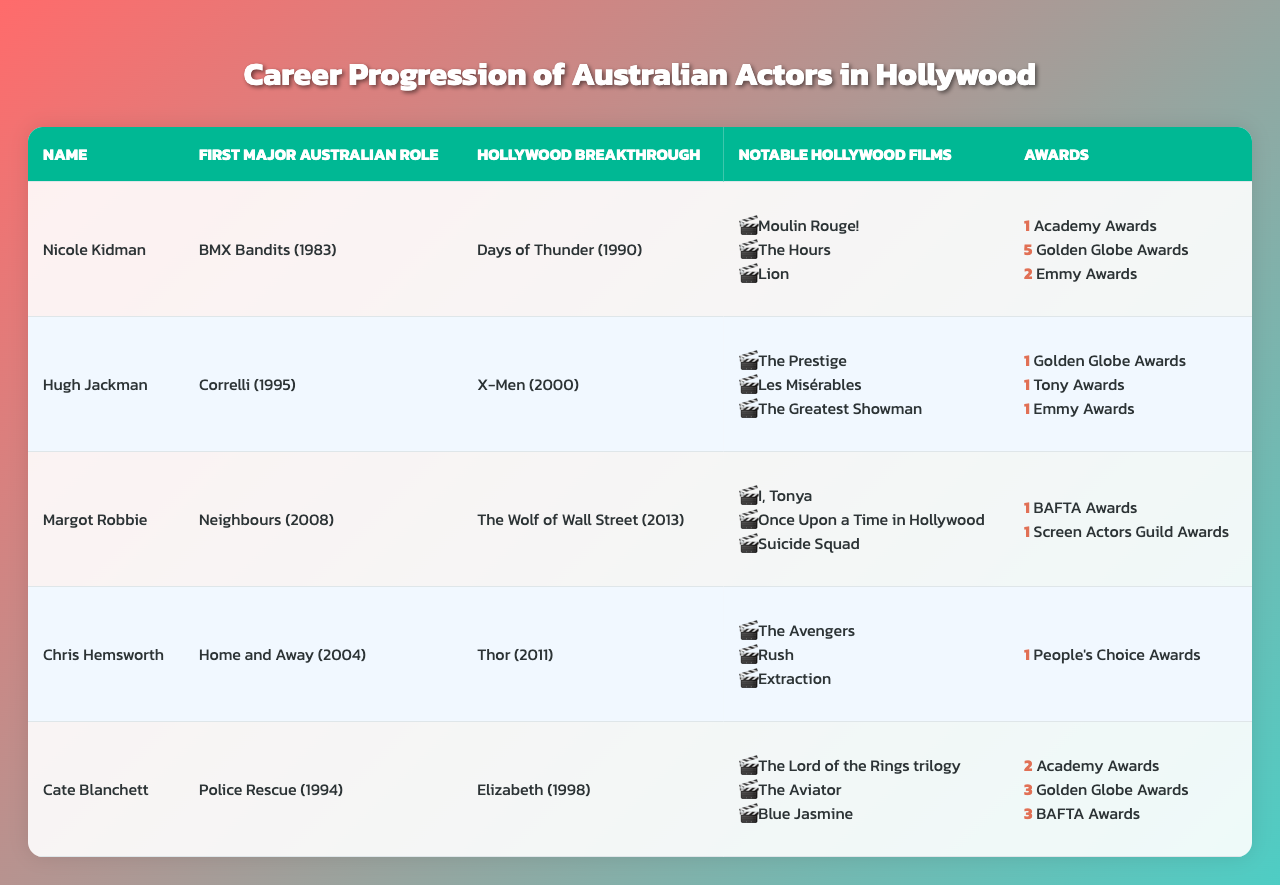What is the first major Australian role of Hugh Jackman? The table shows that Hugh Jackman's first major Australian role was in "Correlli," which was released in 1995.
Answer: Correlli How many Academy Awards has Cate Blanchett won? According to the table, Cate Blanchett has won 2 Academy Awards.
Answer: 2 What year did Nicole Kidman have her Hollywood breakthrough? The table indicates that Nicole Kidman's Hollywood breakthrough was with "Days of Thunder," which occurred in 1990.
Answer: 1990 Which actor won the most Golden Globe Awards? By examining the table, Nicole Kidman has the highest number of Golden Globe Awards, with a total of 5.
Answer: Nicole Kidman List one notable film for Margot Robbie. The table contains several notable films for Margot Robbie, such as "I, Tonya," which can be mentioned as a valid answer.
Answer: I, Tonya Is Chris Hemsworth's first major Australian role before or after 2000? The table states that Chris Hemsworth's first major Australian role was in "Home and Away," which was in 2004, thus it is after 2000.
Answer: After What is the total number of awards won by Nicole Kidman? Nicole Kidman has won 1 Academy Award, 5 Golden Globe Awards, and 2 Emmy Awards, totaling 8 awards when summed up (1 + 5 + 2 = 8).
Answer: 8 Which actor made their Hollywood breakthrough with a film released in 2011? The table shows that Chris Hemsworth had his Hollywood breakthrough with "Thor," which was released in 2011.
Answer: Chris Hemsworth Did any of the featured actors star in "The Avengers"? The table lists "The Avengers" as a notable film for Chris Hemsworth, confirming that he starred in it.
Answer: Yes Which two actors have won BAFTA Awards? Referring to the table, Cate Blanchett has won 3 BAFTA Awards, while Margot Robbie has won 1 BAFTA Award, making a total of two actors.
Answer: Cate Blanchett and Margot Robbie What is the difference between the number of Academy Awards won by Cate Blanchett and Nicole Kidman? The table shows that Cate Blanchett has won 2 Academy Awards and Nicole Kidman has won 1, so the difference is (2 - 1 = 1).
Answer: 1 